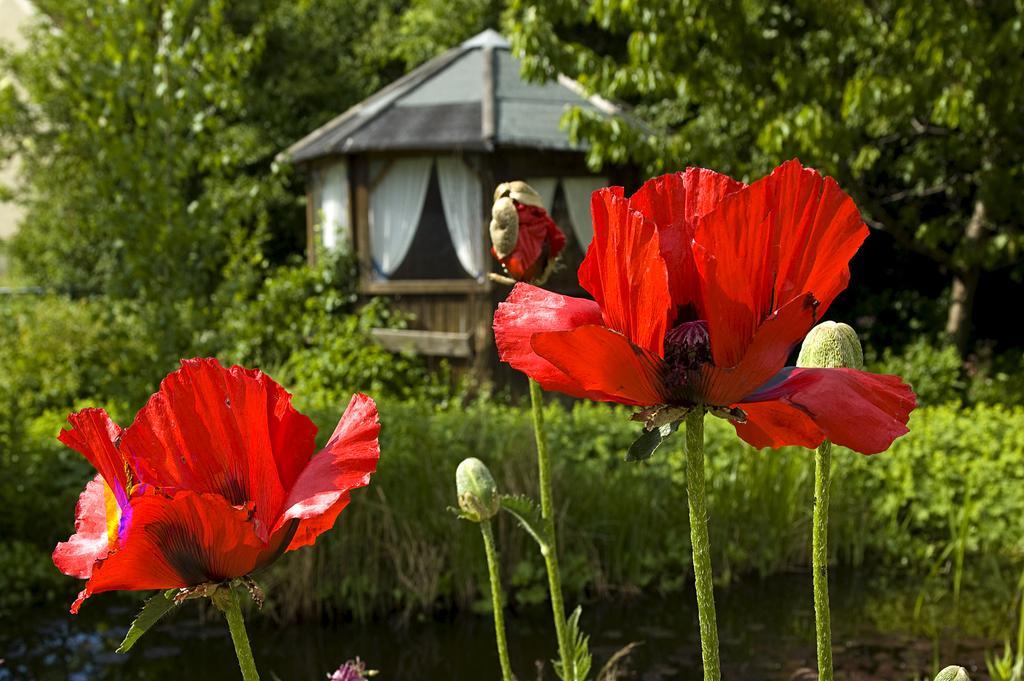In one or two sentences, can you explain what this image depicts? In this image we can see some flowers, buds, plants, trees, also we can see a house, and curtains. 